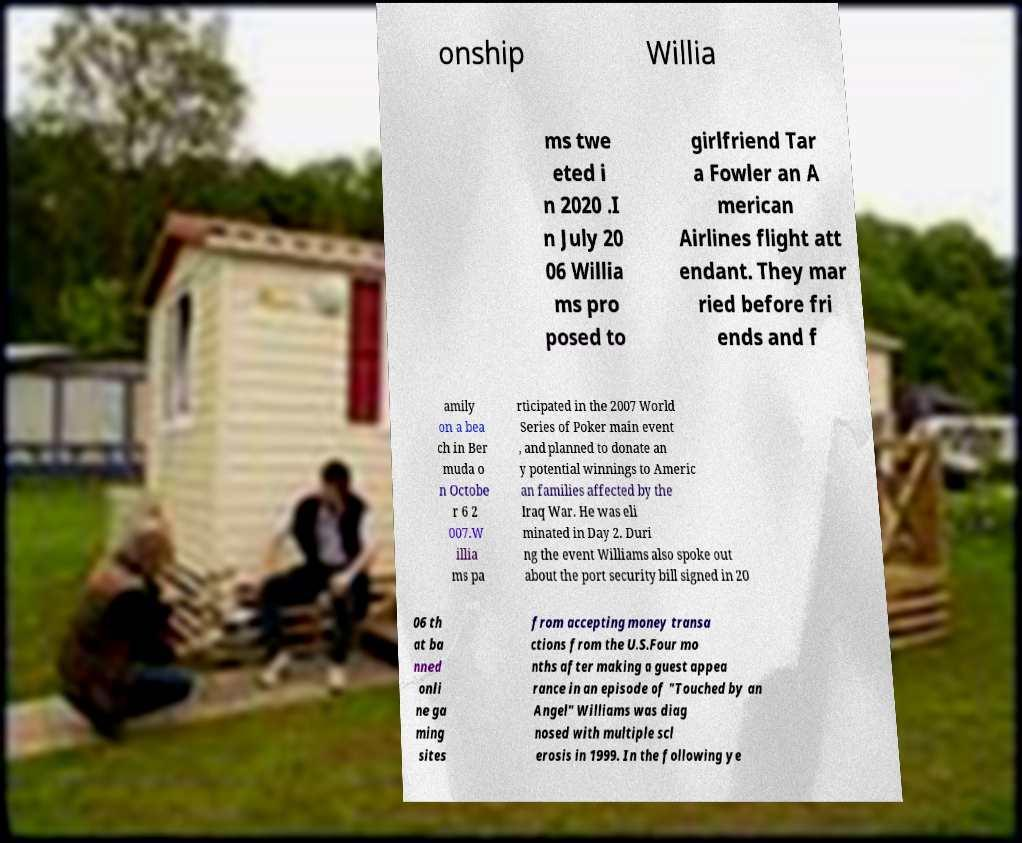Can you read and provide the text displayed in the image?This photo seems to have some interesting text. Can you extract and type it out for me? onship Willia ms twe eted i n 2020 .I n July 20 06 Willia ms pro posed to girlfriend Tar a Fowler an A merican Airlines flight att endant. They mar ried before fri ends and f amily on a bea ch in Ber muda o n Octobe r 6 2 007.W illia ms pa rticipated in the 2007 World Series of Poker main event , and planned to donate an y potential winnings to Americ an families affected by the Iraq War. He was eli minated in Day 2. Duri ng the event Williams also spoke out about the port security bill signed in 20 06 th at ba nned onli ne ga ming sites from accepting money transa ctions from the U.S.Four mo nths after making a guest appea rance in an episode of "Touched by an Angel" Williams was diag nosed with multiple scl erosis in 1999. In the following ye 